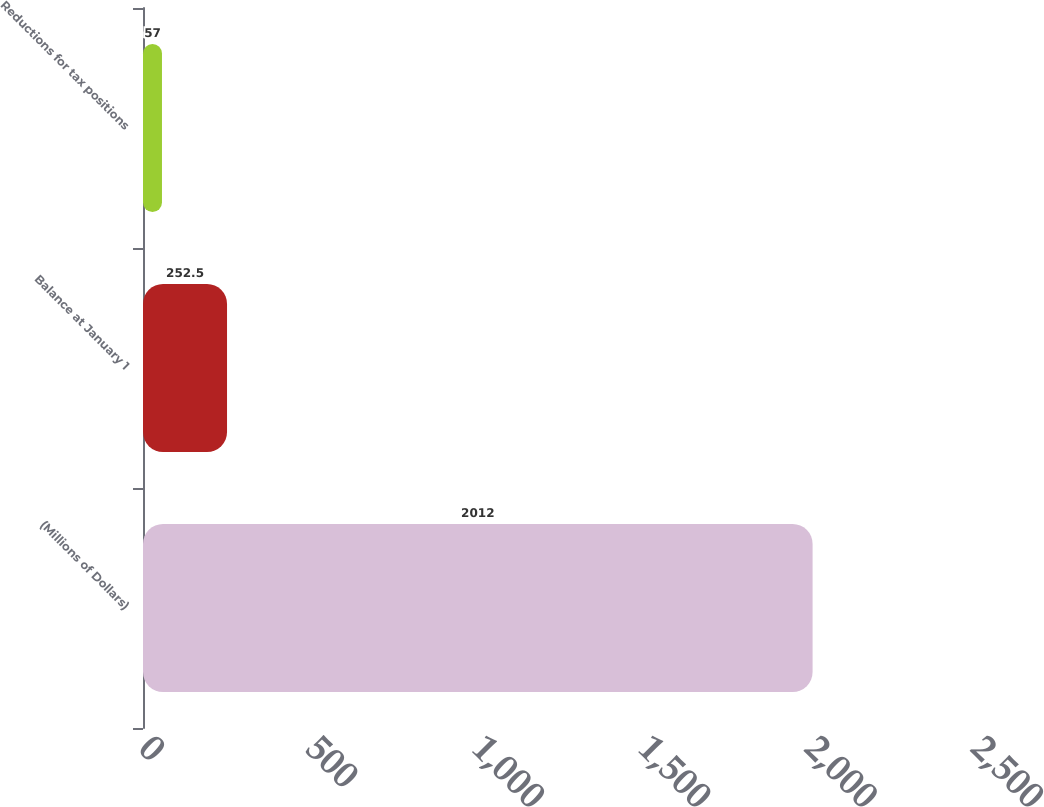Convert chart. <chart><loc_0><loc_0><loc_500><loc_500><bar_chart><fcel>(Millions of Dollars)<fcel>Balance at January 1<fcel>Reductions for tax positions<nl><fcel>2012<fcel>252.5<fcel>57<nl></chart> 